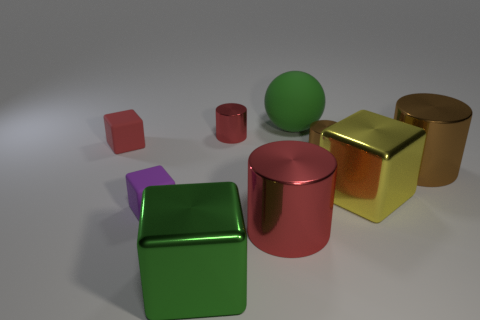Subtract all yellow blocks. How many blocks are left? 3 Add 1 cyan metal spheres. How many objects exist? 10 Subtract all red cylinders. How many cylinders are left? 2 Subtract all purple balls. How many brown cylinders are left? 2 Subtract all balls. How many objects are left? 8 Subtract all red cylinders. Subtract all large brown rubber cylinders. How many objects are left? 7 Add 5 large red metallic objects. How many large red metallic objects are left? 6 Add 9 big green rubber spheres. How many big green rubber spheres exist? 10 Subtract 1 purple cubes. How many objects are left? 8 Subtract 1 spheres. How many spheres are left? 0 